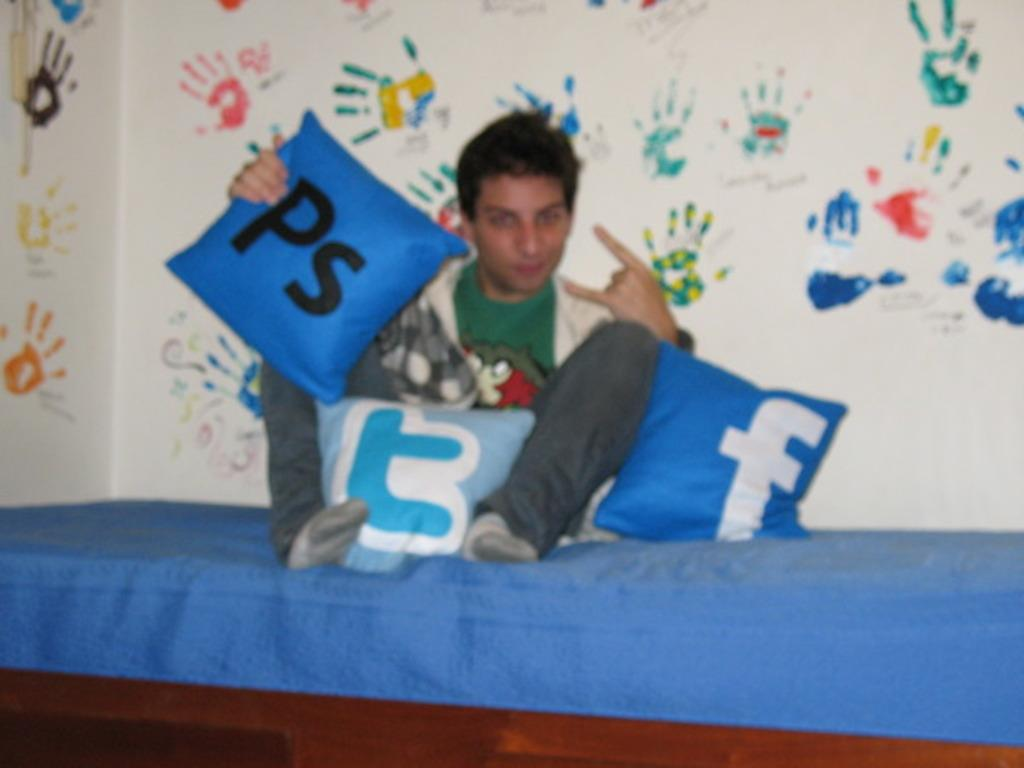What is the man in the image doing? The man is sitting on a bed in the image. What objects are near the man? There are pillows near the man. What can be seen behind the man? There is a wall behind the man. Are there any marks or features on the wall? Yes, there are handprints on the wall. What type of list can be seen hanging on the wall in the image? There is no list present on the wall in the image; only handprints are visible. 